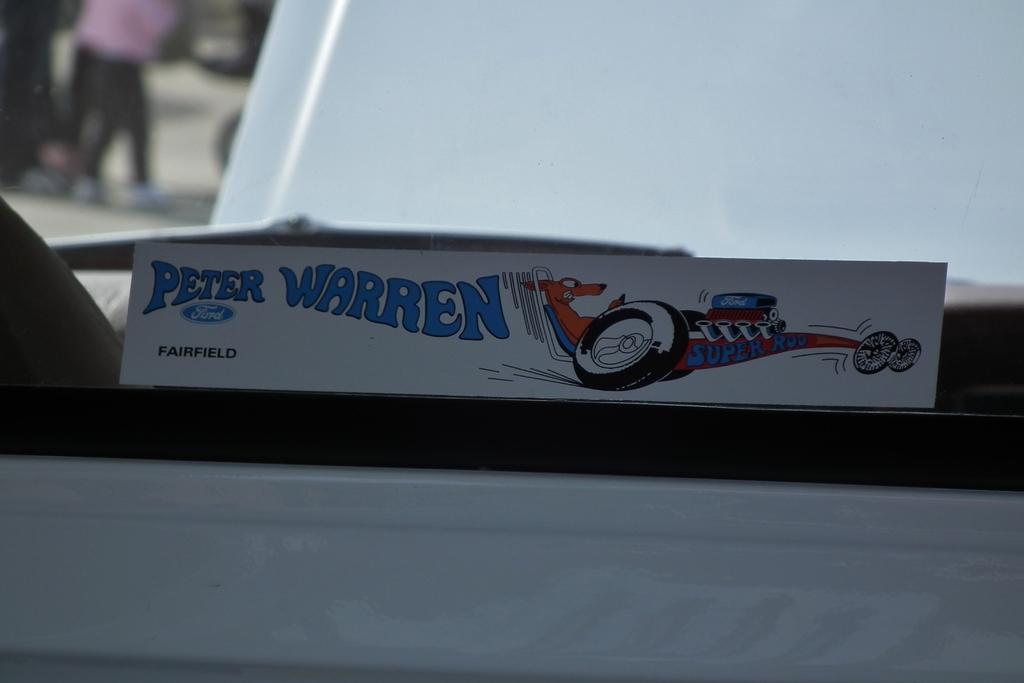Please provide a concise description of this image. In the image we can see there is a paper pasted on the glass and on it it's written ¨Peter Warren¨. There is a cartoon of a dog sitting in a racing car is drawn on the paper. Behind the image is blur. 